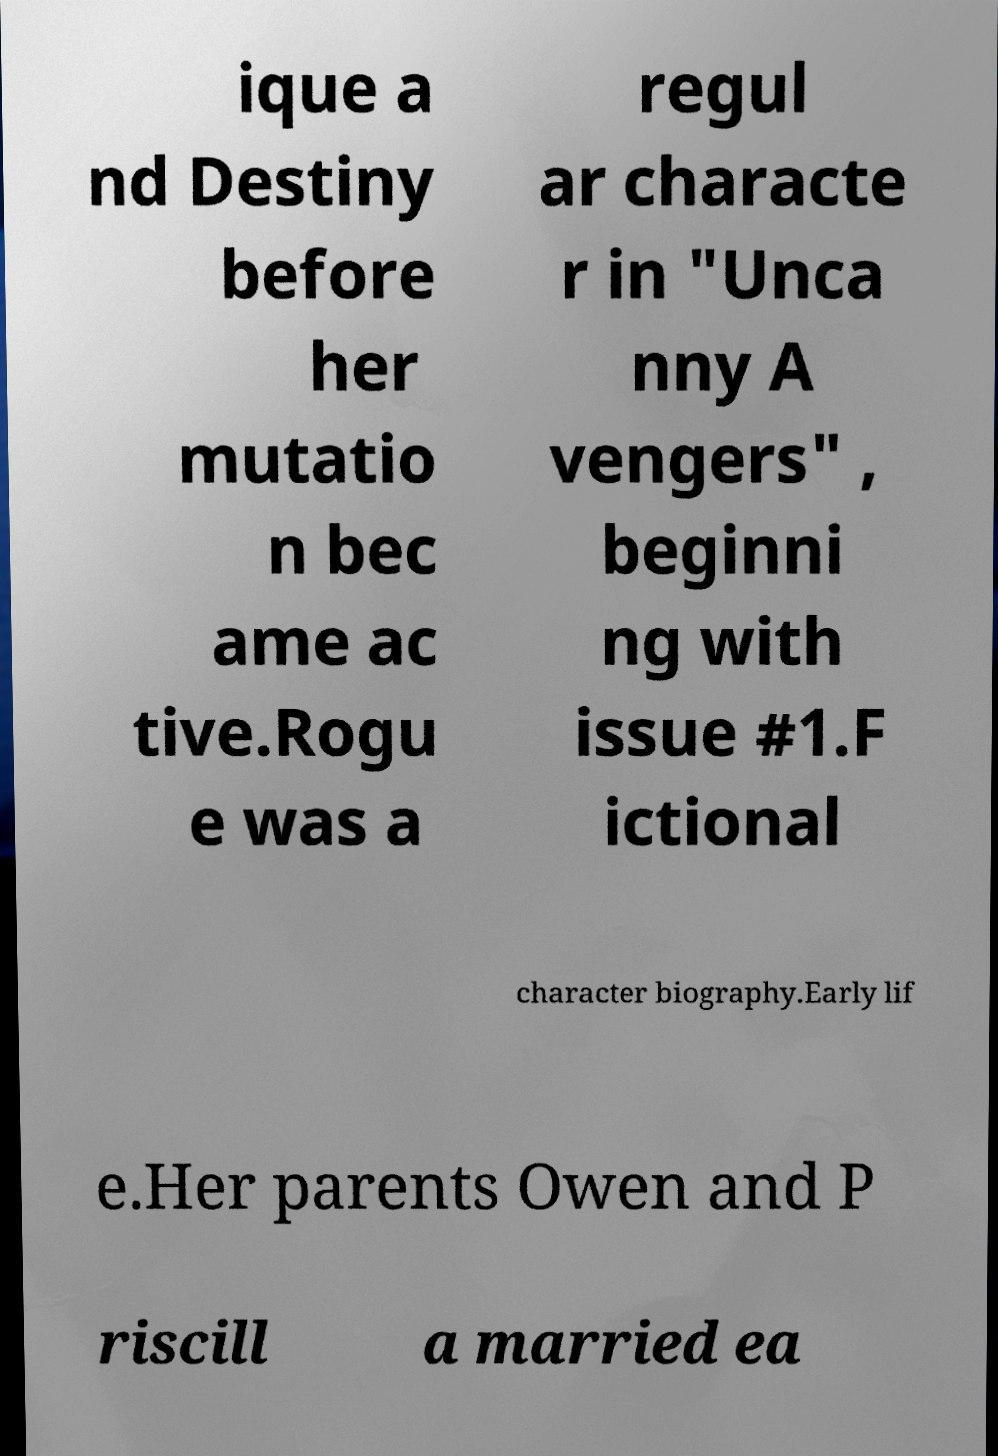Could you extract and type out the text from this image? ique a nd Destiny before her mutatio n bec ame ac tive.Rogu e was a regul ar characte r in "Unca nny A vengers" , beginni ng with issue #1.F ictional character biography.Early lif e.Her parents Owen and P riscill a married ea 